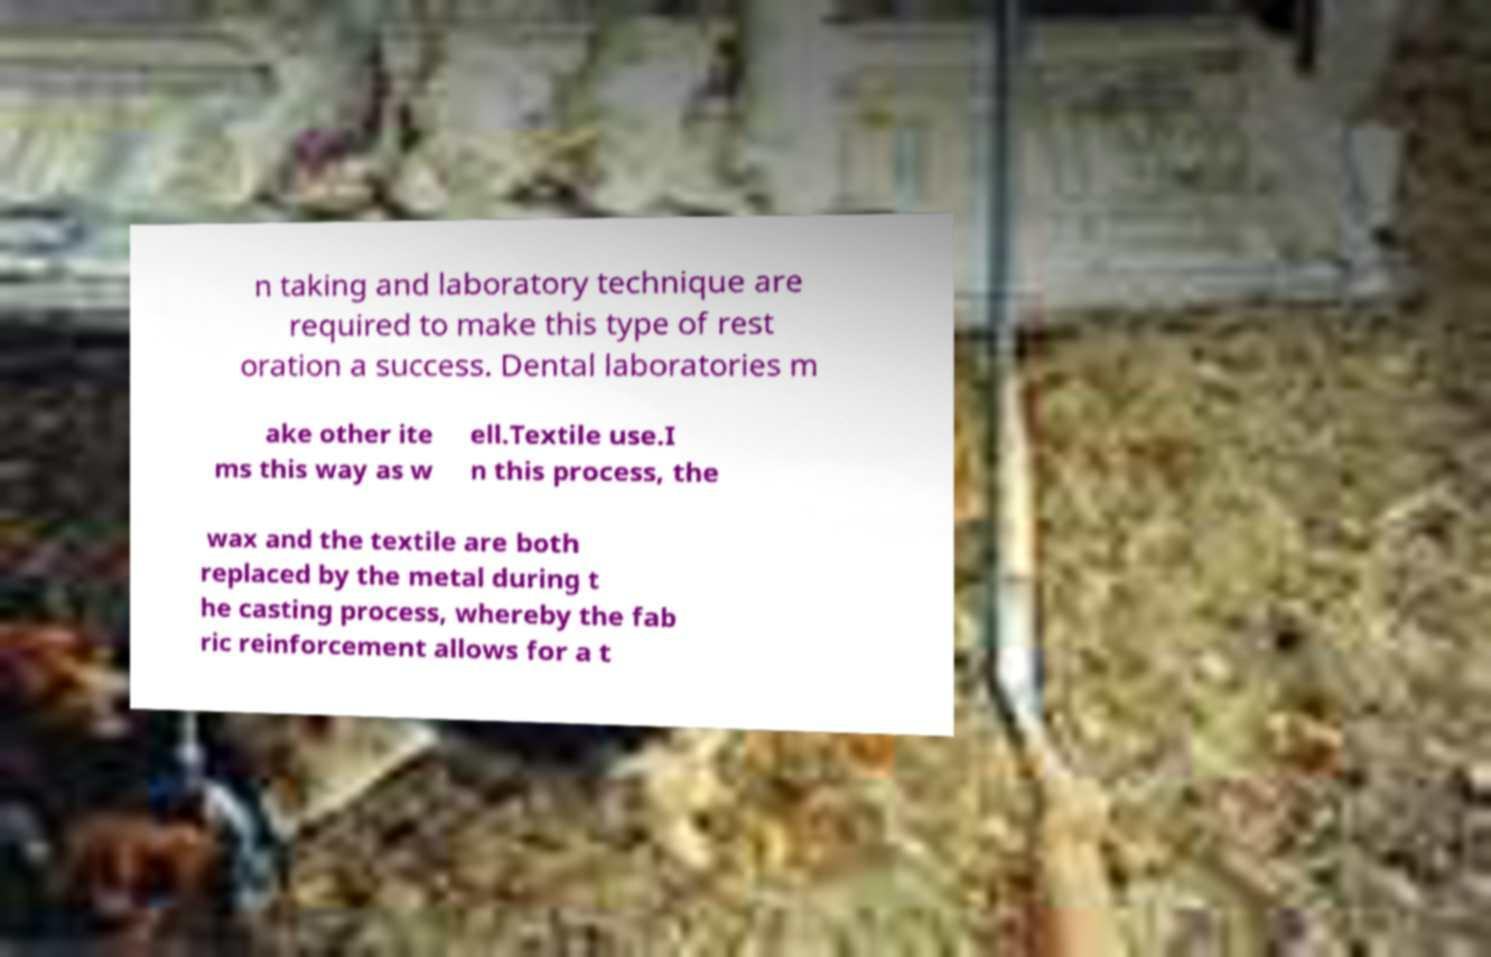I need the written content from this picture converted into text. Can you do that? n taking and laboratory technique are required to make this type of rest oration a success. Dental laboratories m ake other ite ms this way as w ell.Textile use.I n this process, the wax and the textile are both replaced by the metal during t he casting process, whereby the fab ric reinforcement allows for a t 